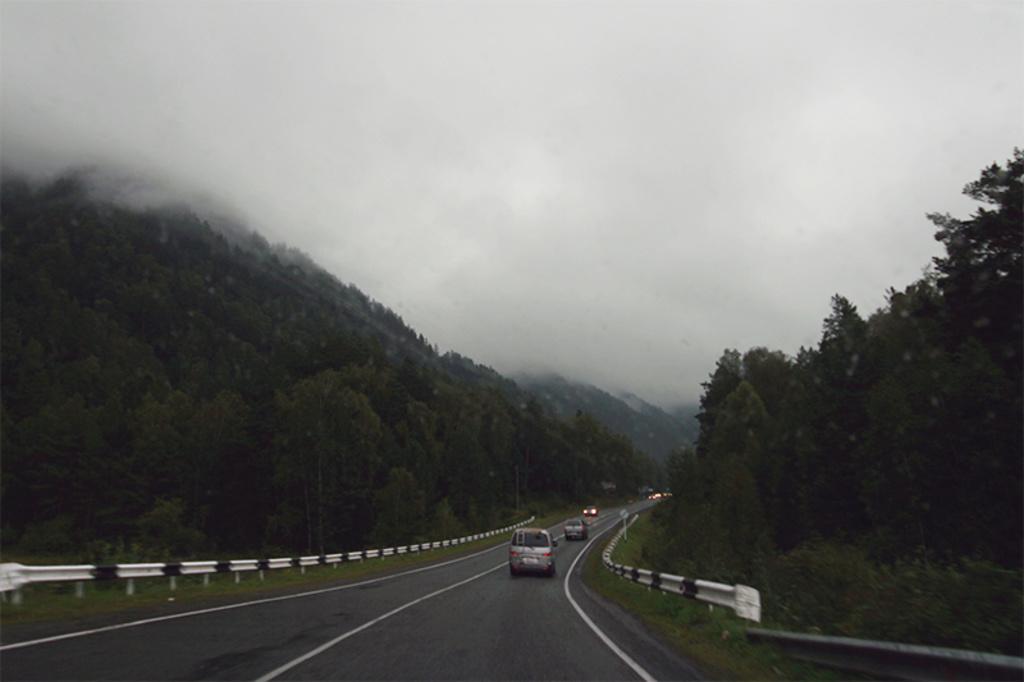In one or two sentences, can you explain what this image depicts? This image is clicked on the road. At the bottom, there is a road. On the left and right, there are trees and fencing. At the top, there is sky along with the fog. 